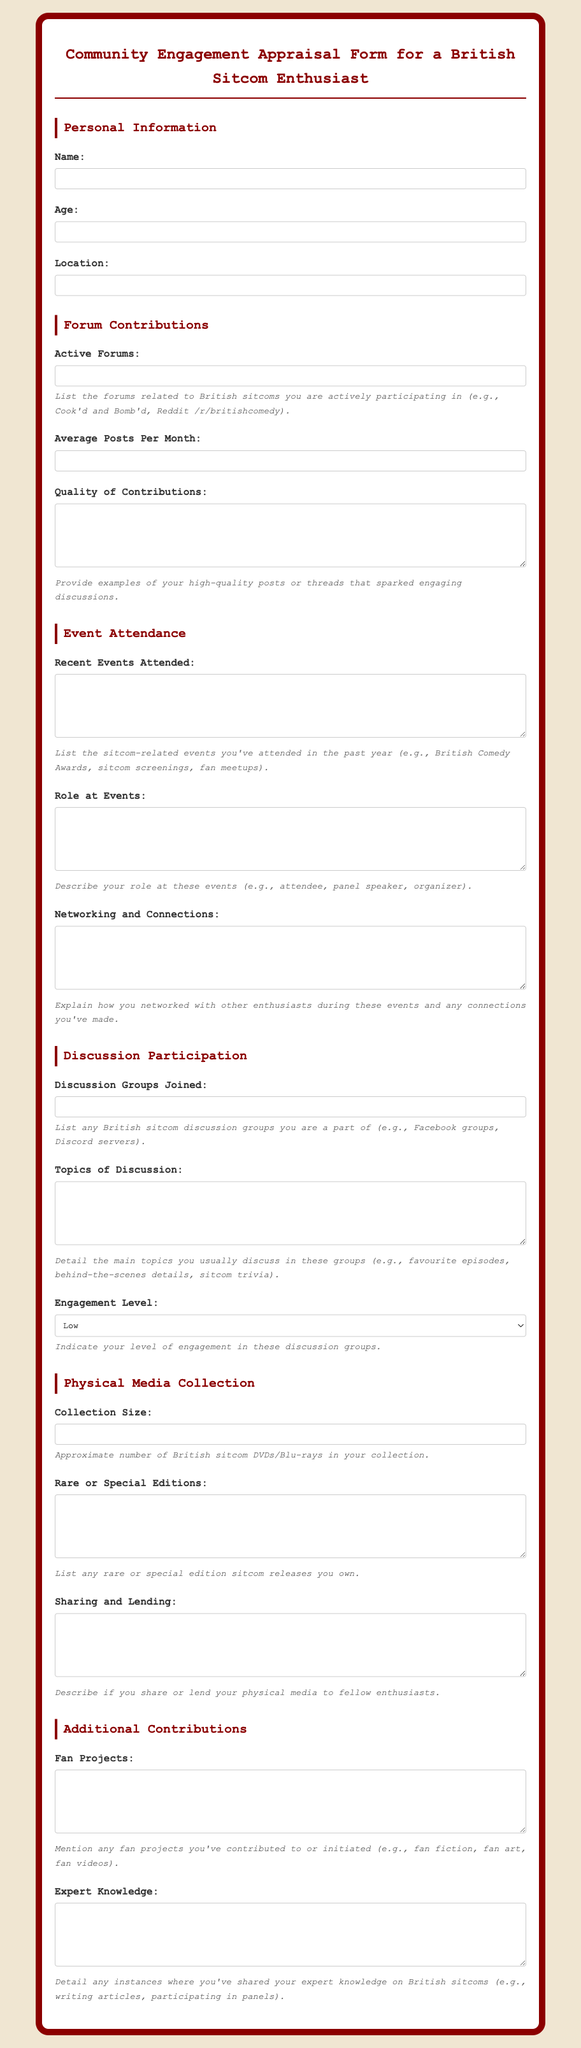What is the title of the document? The title of the document, as indicated at the top, is "Community Engagement Appraisal Form for a British Sitcom Enthusiast."
Answer: Community Engagement Appraisal Form for a British Sitcom Enthusiast What is the average posts per month field asking for? The average posts per month field is asking for the number of posts made by the enthusiast in forums each month.
Answer: Average Posts Per Month How many types of groups should be listed in the discussion groups section? The discussion groups section instructs to list any British sitcom discussion groups one is a part of.
Answer: Any number What is the role at events section asking about? The role at events section requests a description of the person's role during sitcom-related events attended.
Answer: Role at Events What does the engagement level dropdown include as options? The engagement level dropdown includes three distinct options for selection: Low, Moderate, and High.
Answer: Low, Moderate, High What should you describe in the quality of contributions section? In the quality of contributions section, the enthusiast should provide examples of high-quality posts or threads.
Answer: Examples of high-quality posts How is the description provided in the forum contributions section formatted? The description provided in the forum contributions section is formatted to explain the purpose of the input fields.
Answer: Examples of high-quality posts What type of media does the document specifically mention a collection for? The document specifically mentions a collection for British sitcom DVDs and Blu-rays.
Answer: British sitcom DVDs/Blu-rays What additional contributions are requested in the document? The document requests information about fan projects and expert knowledge related to British sitcoms.
Answer: Fan projects and expert knowledge 